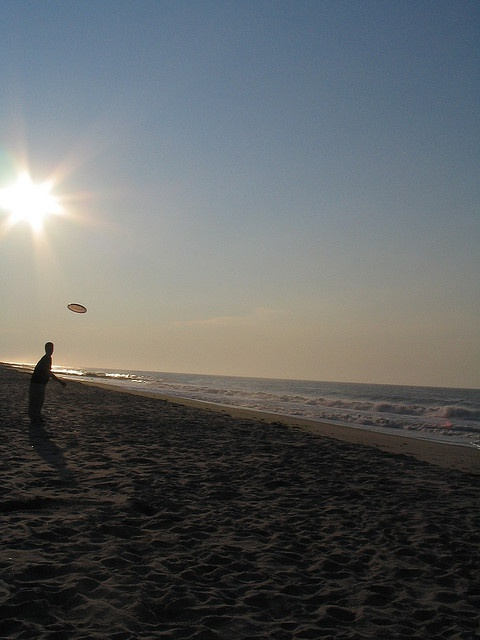Describe the objects in this image and their specific colors. I can see people in gray, black, maroon, and tan tones and frisbee in gray, black, and maroon tones in this image. 